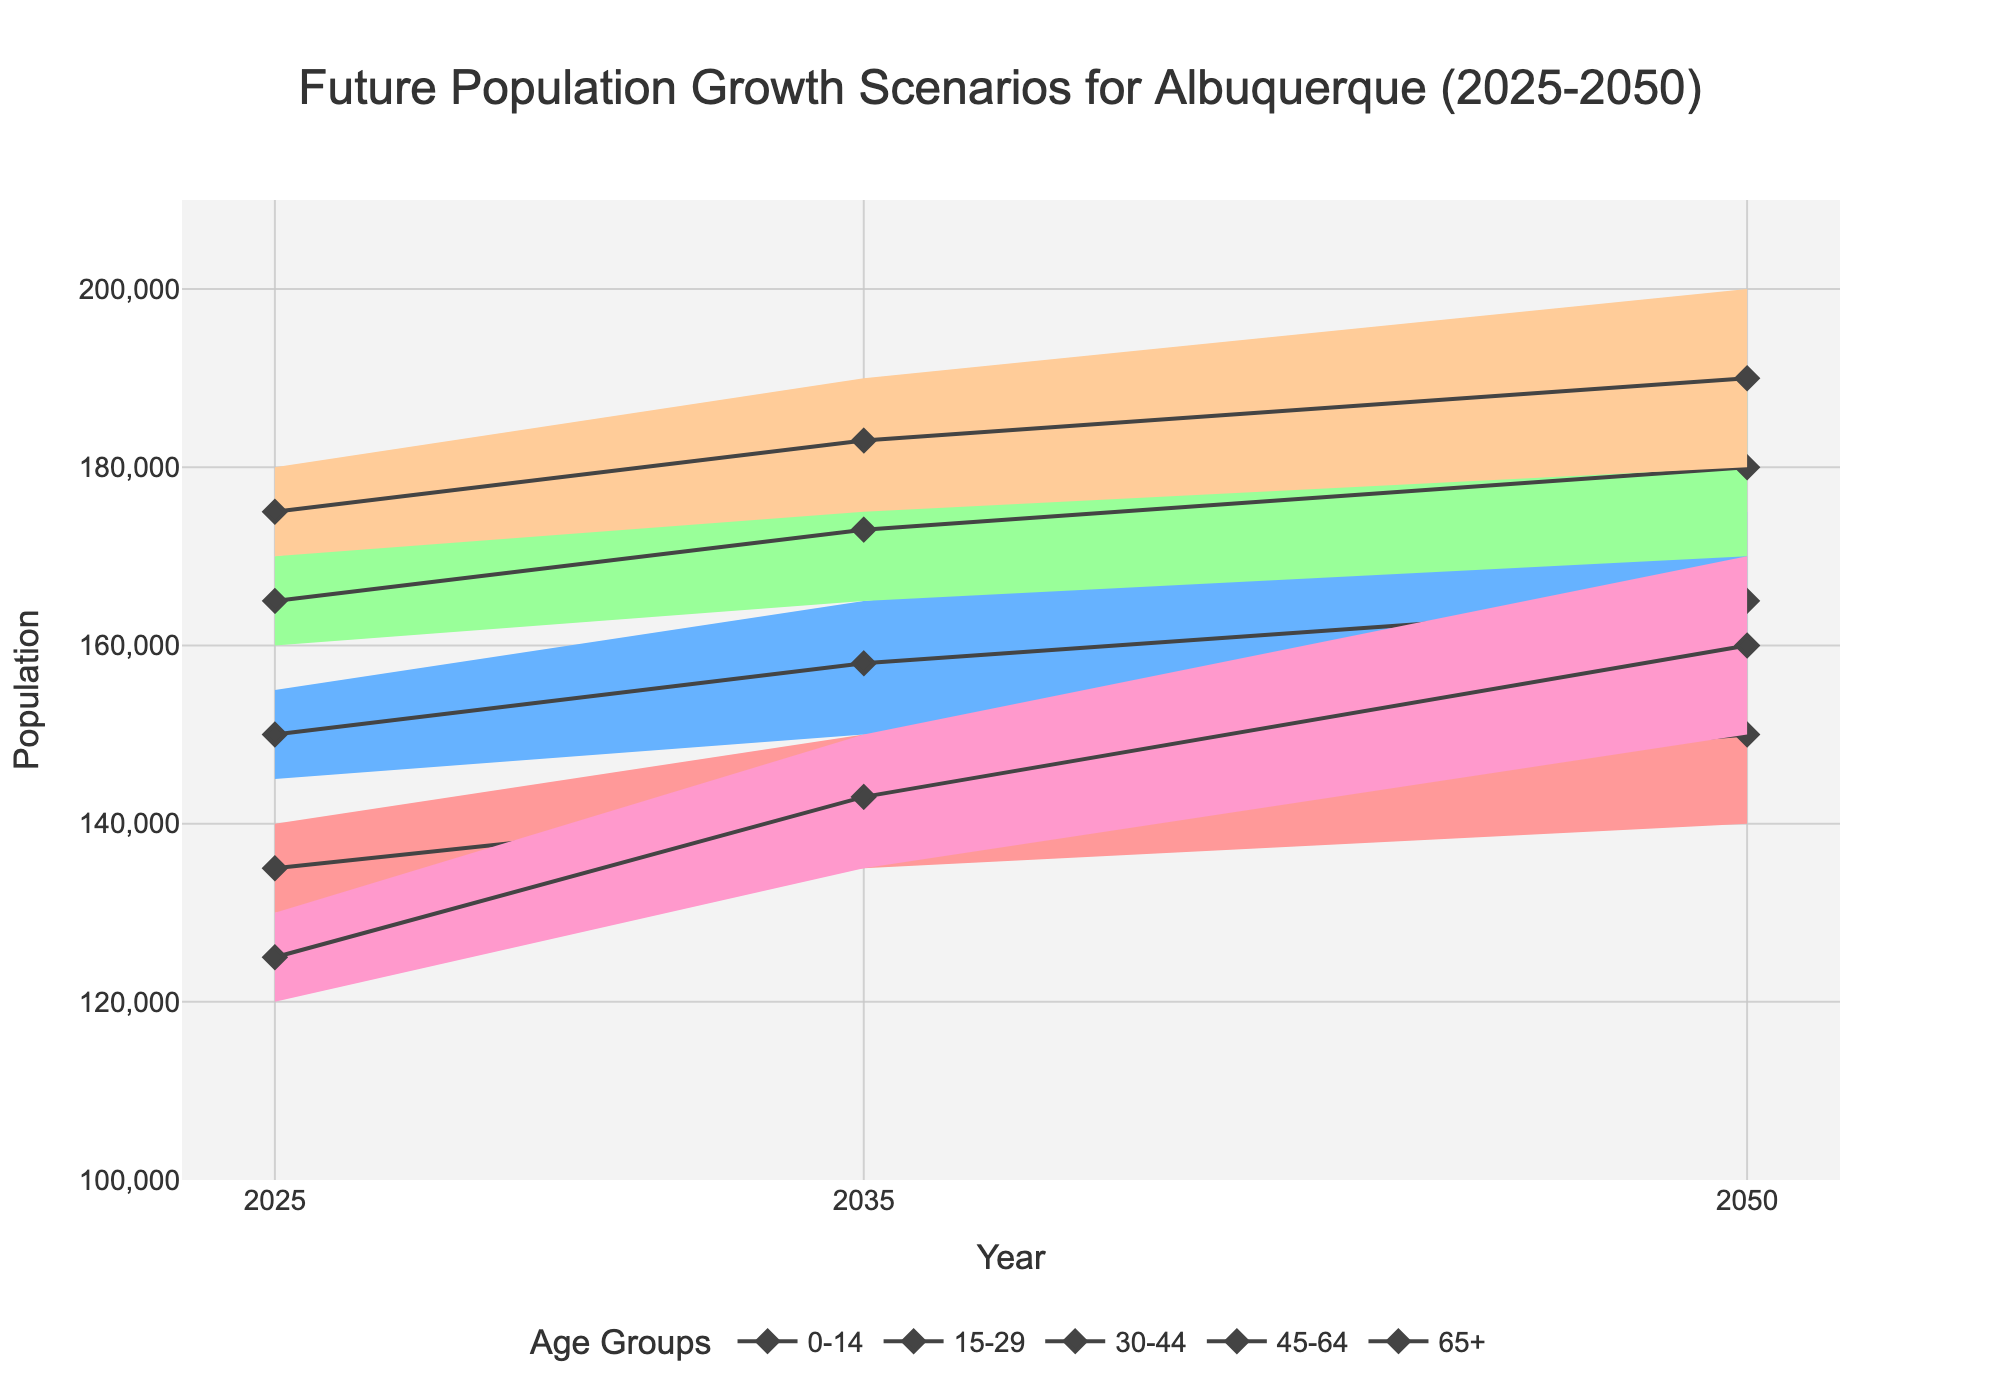What is the title of the chart? The title is found at the top of the chart, and it summarizes what the figure is about.
Answer: Future Population Growth Scenarios for Albuquerque (2025-2050) How many age groups are there in the chart? The figure shows different colors for each age group in the legend and the chart itself. Count the unique colors and labels.
Answer: 5 In 2050, which age group has the lowest high estimate? Identify the age group with the smallest value in the "High Estimate" column for 2050 by looking at the top edge of the shaded areas in the chart for that year.
Answer: 0-14 Which age group has the most significant increase in the high estimate from 2025 to 2050? Find the difference between the high estimate in 2050 and 2025 for each age group, then compare these differences to determine the largest one.
Answer: 65+ What is the range of the population for the 30-44 age group in 2035? Look at the shaded area for the 30-44 age group in 2035, find the difference between the high and low estimates to determine the range.
Answer: 35,000 Which year has the highest low estimate for the 0-14 age group? Compare the low estimates for the 0-14 age group across all years and identify the largest value.
Answer: 2050 What is the medium estimate for the 45-64 age group in 2025? Find the central line (medium estimate) for the 45-64 age group in 2025.
Answer: 175,000 How does the population of the 65+ age group change from 2025 to 2050 across the medium estimates? Compare the medium estimates for the 65+ age group in 2025 and 2050 to calculate the change.
Answer: Increase by 35,000 Which age group is expected to have a higher population range in 2035, 0-14 or 65+? Compare the differences between the high and low estimates for both age groups in 2035.
Answer: 65+ Which years exhibit a noticeable population increase for the 15-29 age group according to the high estimate line? Identify the trend in the high estimate line for the 15-29 age group to see where significant increases occur.
Answer: 2025-2050 